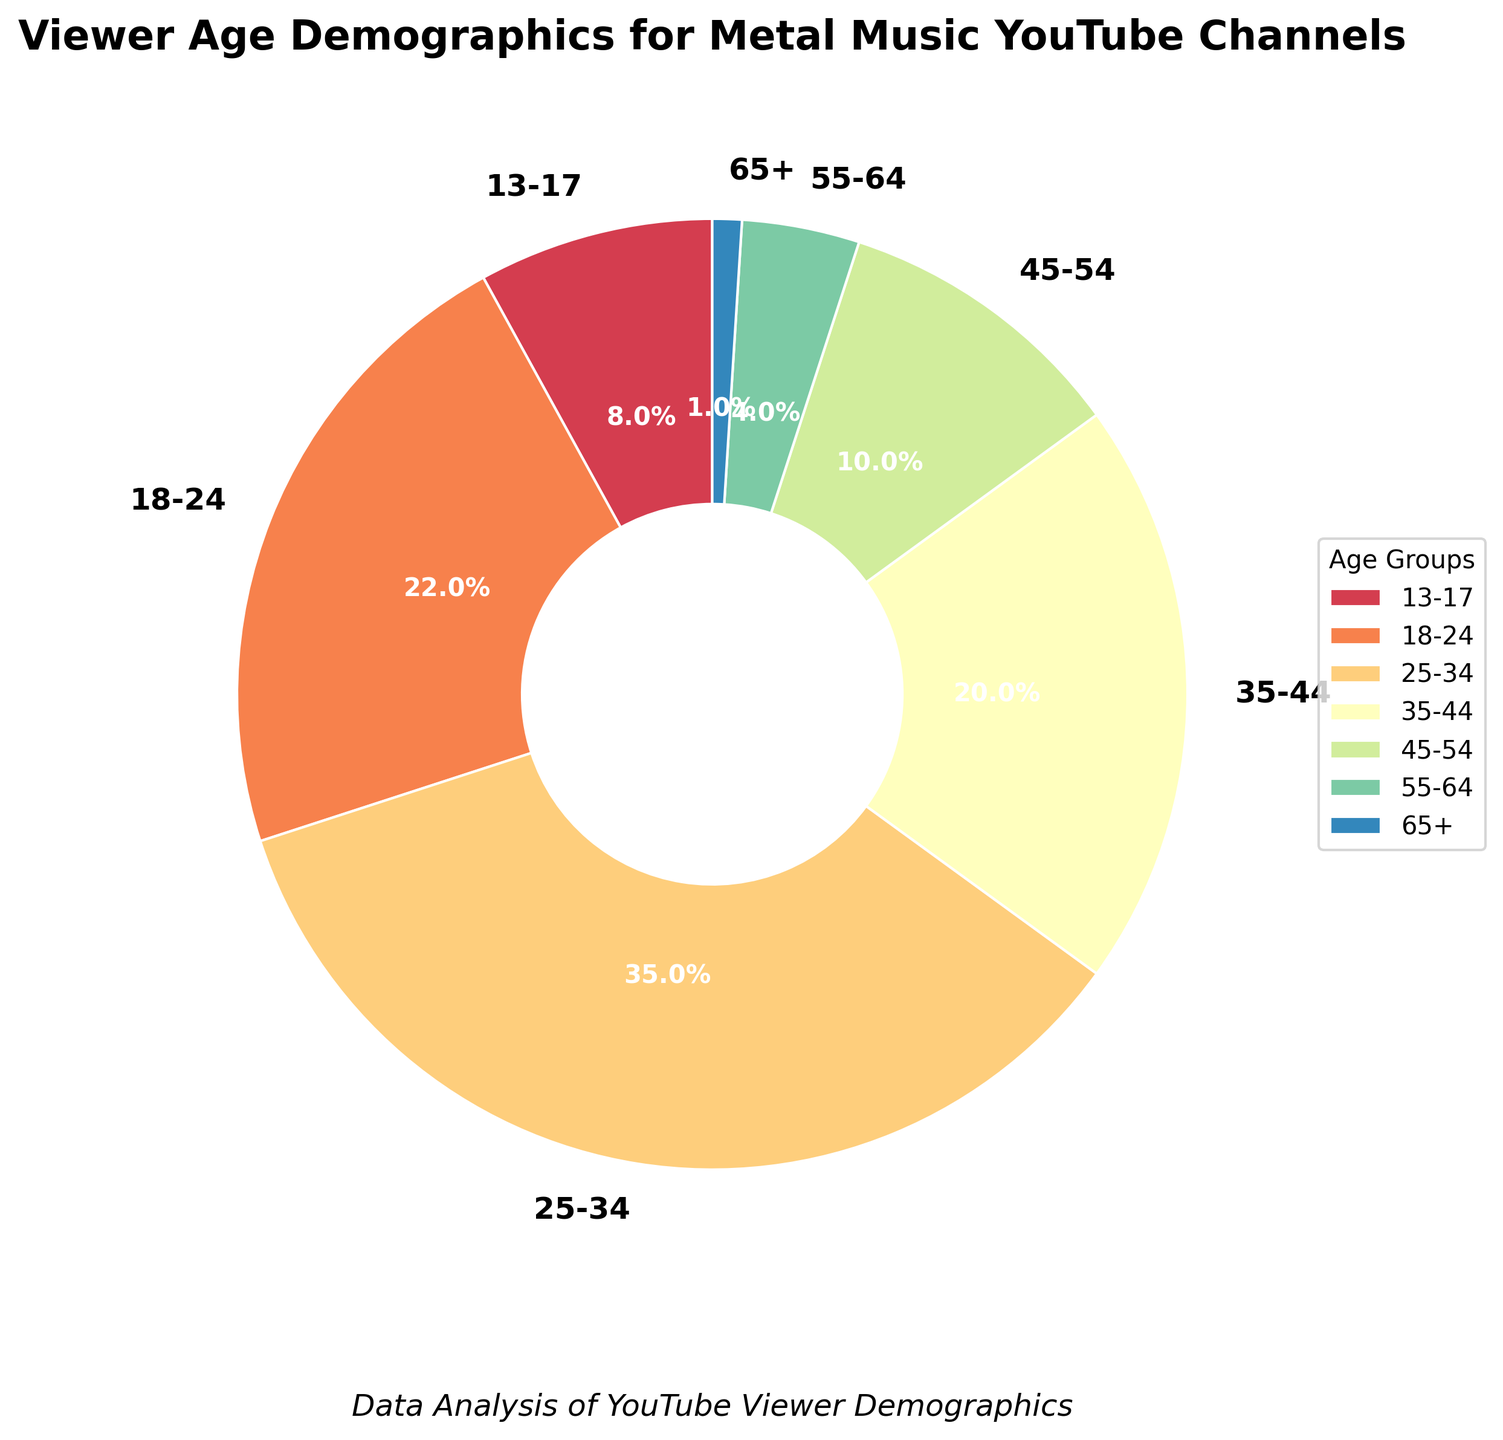What age group represents the largest percentage of viewers? The slice representing the 25-34 age group is the largest on the pie chart, indicating it has the highest percentage.
Answer: 25-34 Which age group has a higher percentage of viewers: 18-24 or 35-44? The pie chart shows that the 18-24 age group has a larger slice compared to the 35-44 age group. The percentage for 18-24 is 22%, while for 35-44 it is 20%.
Answer: 18-24 What is the combined percentage of viewers aged 45 and above? To find the combined percentage of viewers aged 45 and above, add the percentages of the 45-54, 55-64, and 65+ age groups: 10% + 4% + 1%. The sum is 15%.
Answer: 15% Is the percentage of viewers aged 13-17 higher or lower than the percentage of viewers aged 55-64? By inspecting the slices for the 13-17 and 55-64 age groups, it is clear that the 13-17 slice is larger. The percentage for 13-17 is 8%, while for 55-64 it is 4%.
Answer: Higher What is the ratio of viewers aged 25-34 to viewers aged 18-24? The percentage for the 25-34 age group is 35%, and for the 18-24 age group, it is 22%. The ratio is 35% divided by 22%, which simplifies to approximately 1.59.
Answer: 1.59 What percentage of viewers are below 35 years of age? To calculate the percentage of viewers below 35 years of age, add the percentages of the 13-17, 18-24, and 25-34 age groups: 8% + 22% + 35%. The sum is 65%.
Answer: 65% Which age group has a smaller percentage of viewers: 35-44 or 45-54? By observing the slices for the 35-44 and 45-54 age groups, the 45-54 slice is smaller. The percentage for 35-44 is 20%, and for 45-54, it is 10%.
Answer: 45-54 